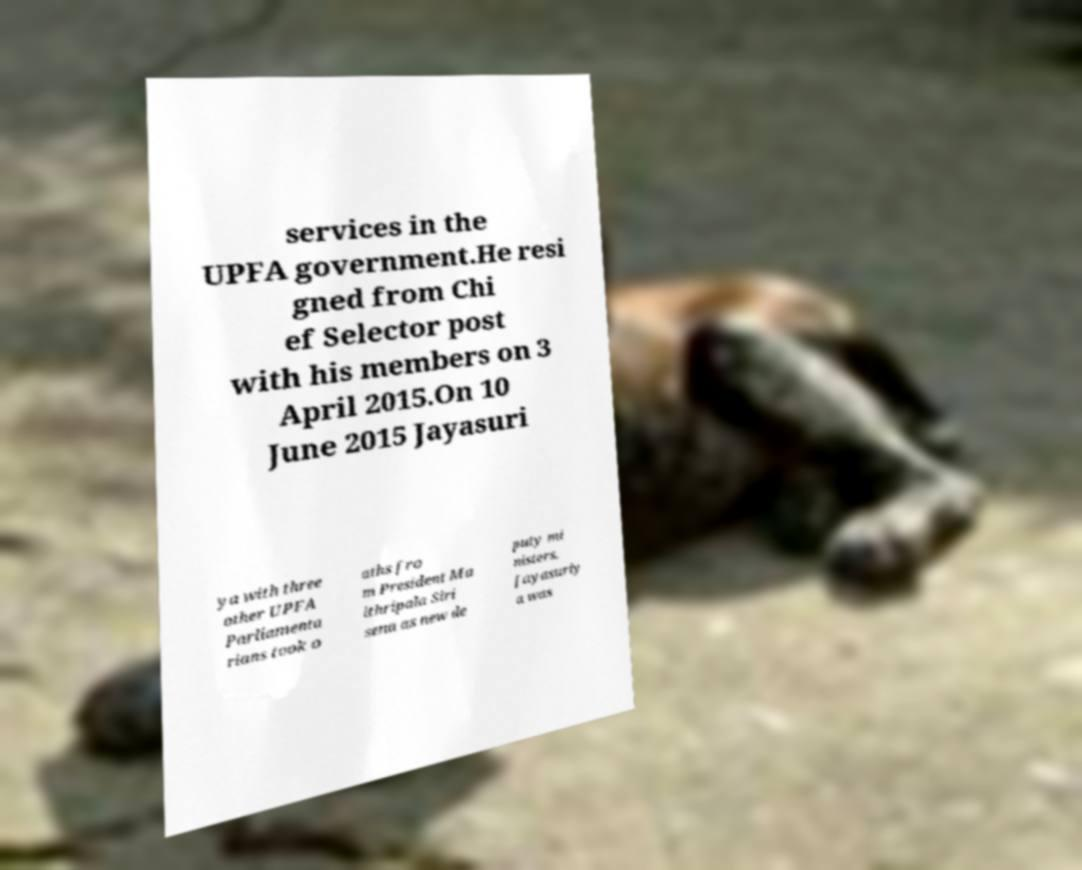Please read and relay the text visible in this image. What does it say? services in the UPFA government.He resi gned from Chi ef Selector post with his members on 3 April 2015.On 10 June 2015 Jayasuri ya with three other UPFA Parliamenta rians took o aths fro m President Ma ithripala Siri sena as new de puty mi nisters. Jayasuriy a was 